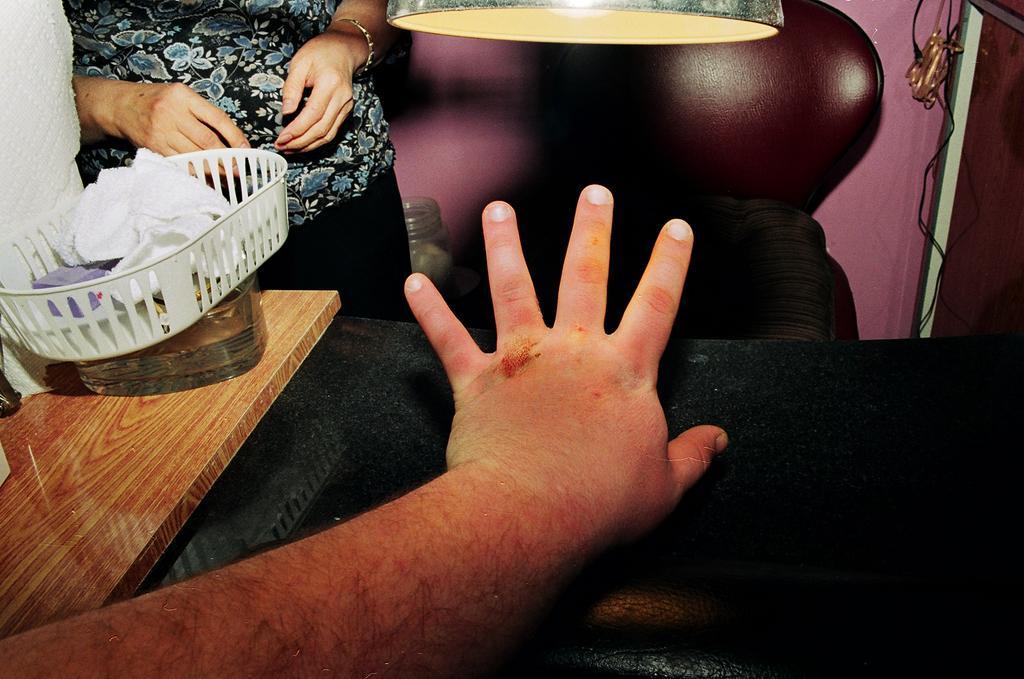Describe this image in one or two sentences. In this image there are two persons, there are boxes and some other objects on the table, a chair, a light and a cable hanging from the wall. 